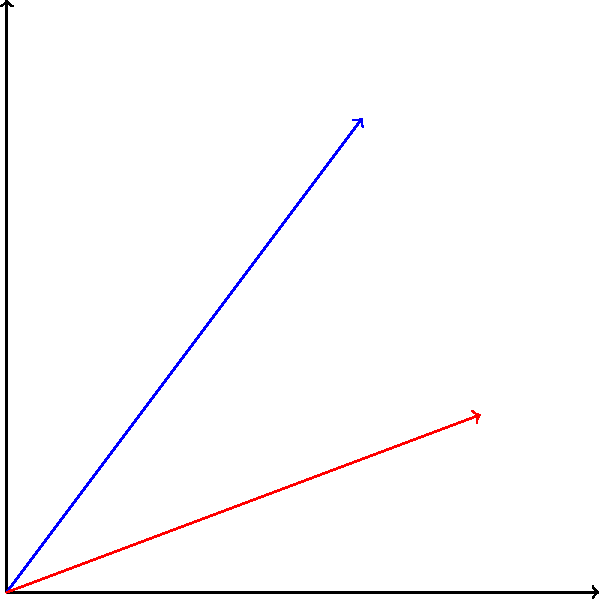At an EDM festival, two DJ speakers are producing interfering sound waves represented by vectors $\vec{A}$ and $\vec{B}$. If $\vec{A} = 6\hat{i} + 8\hat{j}$ and $\vec{B} = 8\hat{i} + 3\hat{j}$, what is the magnitude of the resultant vector $\vec{R}$ to the nearest whole number? To find the magnitude of the resultant vector $\vec{R}$, we'll follow these steps:

1) First, we need to add vectors $\vec{A}$ and $\vec{B}$ to get $\vec{R}$:
   $\vec{R} = \vec{A} + \vec{B}$

2) Adding the components:
   $\vec{R} = (6\hat{i} + 8\hat{j}) + (8\hat{i} + 3\hat{j})$
   $\vec{R} = (6+8)\hat{i} + (8+3)\hat{j}$
   $\vec{R} = 14\hat{i} + 11\hat{j}$

3) Now that we have $\vec{R}$, we can calculate its magnitude using the Pythagorean theorem:
   $|\vec{R}| = \sqrt{x^2 + y^2}$, where $x = 14$ and $y = 11$

4) Plugging in the values:
   $|\vec{R}| = \sqrt{14^2 + 11^2}$
   $|\vec{R}| = \sqrt{196 + 121}$
   $|\vec{R}| = \sqrt{317}$

5) Using a calculator and rounding to the nearest whole number:
   $|\vec{R}| \approx 18$

Therefore, the magnitude of the resultant vector $\vec{R}$ is approximately 18 units.
Answer: 18 